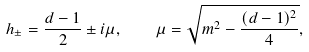Convert formula to latex. <formula><loc_0><loc_0><loc_500><loc_500>h _ { \pm } = \frac { d - 1 } { 2 } \pm i \mu , \quad \mu = \sqrt { { m ^ { 2 } - \frac { ( d - 1 ) ^ { 2 } } { 4 } } } ,</formula> 